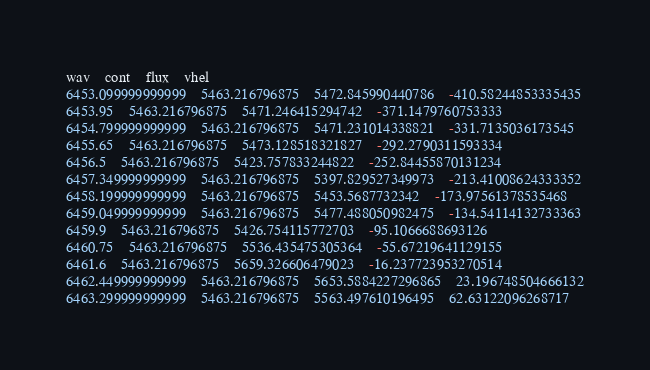Convert code to text. <code><loc_0><loc_0><loc_500><loc_500><_SQL_>wav	cont	flux	vhel
6453.099999999999	5463.216796875	5472.845990440786	-410.58244853335435
6453.95	5463.216796875	5471.246415294742	-371.1479760753333
6454.799999999999	5463.216796875	5471.231014338821	-331.7135036173545
6455.65	5463.216796875	5473.128518321827	-292.2790311593334
6456.5	5463.216796875	5423.757833244822	-252.84455870131234
6457.349999999999	5463.216796875	5397.829527349973	-213.41008624333352
6458.199999999999	5463.216796875	5453.5687732342	-173.97561378535468
6459.049999999999	5463.216796875	5477.488050982475	-134.54114132733363
6459.9	5463.216796875	5426.754115772703	-95.1066688693126
6460.75	5463.216796875	5536.435475305364	-55.67219641129155
6461.6	5463.216796875	5659.326606479023	-16.237723953270514
6462.449999999999	5463.216796875	5653.5884227296865	23.196748504666132
6463.299999999999	5463.216796875	5563.497610196495	62.63122096268717</code> 